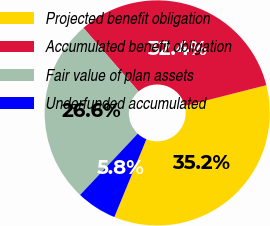Convert chart to OTSL. <chart><loc_0><loc_0><loc_500><loc_500><pie_chart><fcel>Projected benefit obligation<fcel>Accumulated benefit obligation<fcel>Fair value of plan assets<fcel>Underfunded accumulated<nl><fcel>35.19%<fcel>32.41%<fcel>26.61%<fcel>5.79%<nl></chart> 